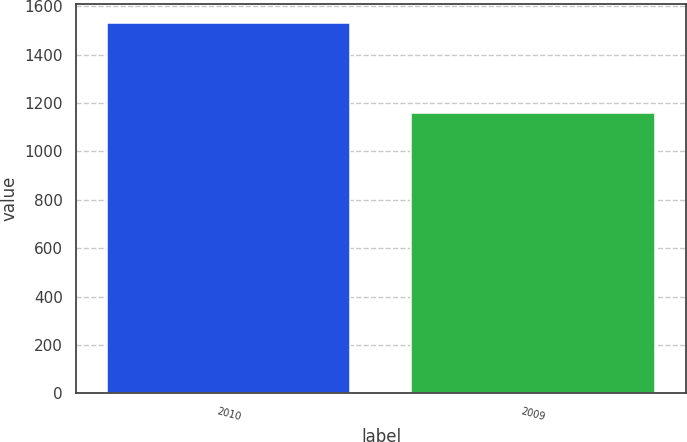Convert chart to OTSL. <chart><loc_0><loc_0><loc_500><loc_500><bar_chart><fcel>2010<fcel>2009<nl><fcel>1532<fcel>1157<nl></chart> 